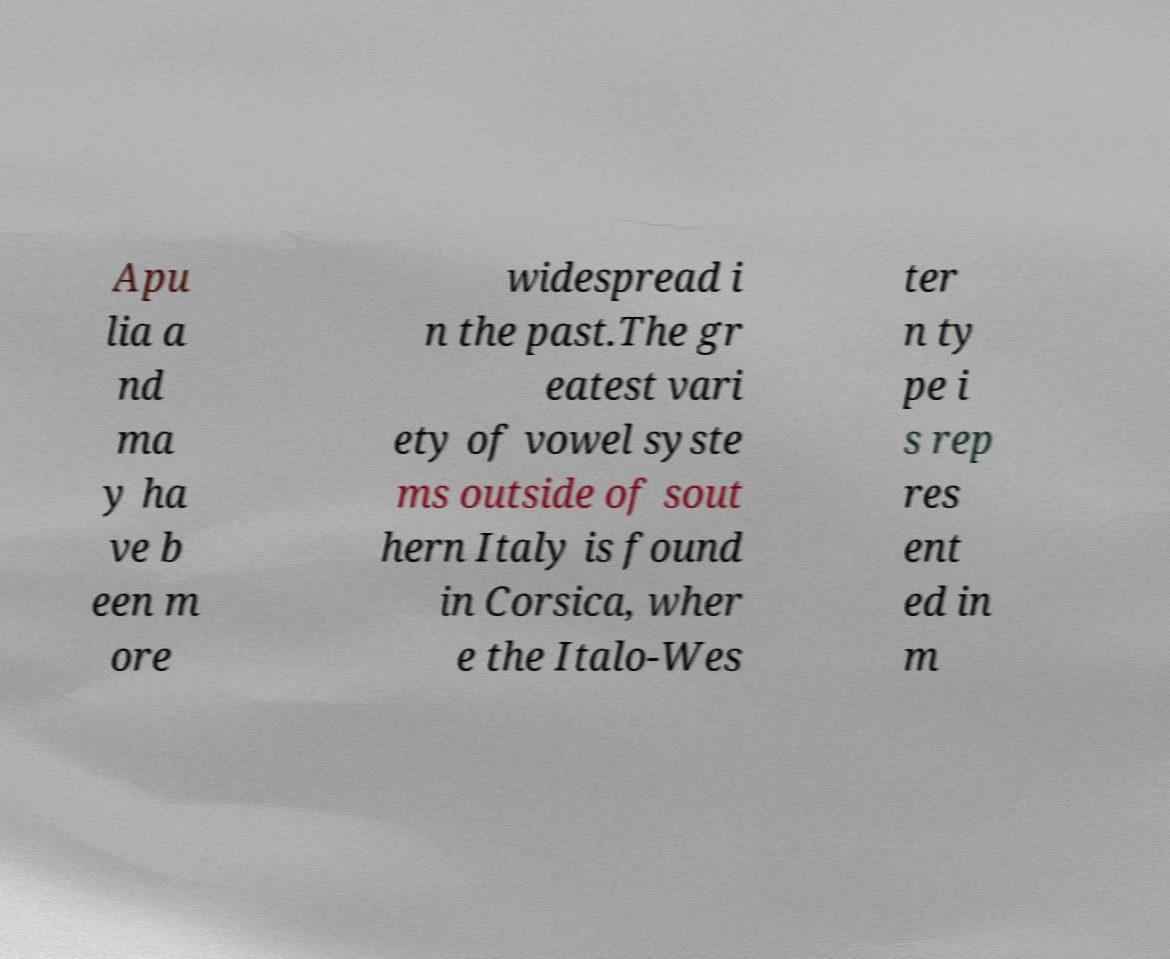I need the written content from this picture converted into text. Can you do that? Apu lia a nd ma y ha ve b een m ore widespread i n the past.The gr eatest vari ety of vowel syste ms outside of sout hern Italy is found in Corsica, wher e the Italo-Wes ter n ty pe i s rep res ent ed in m 